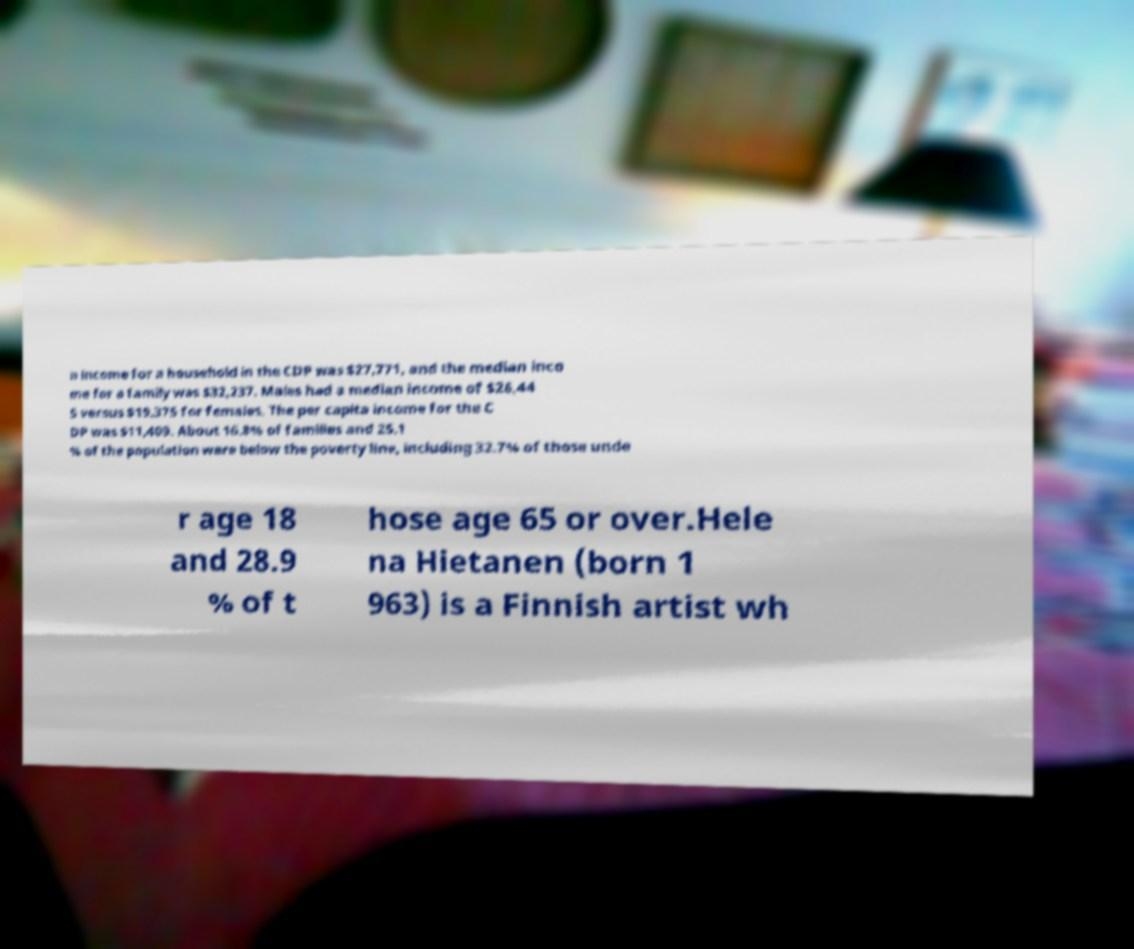Could you extract and type out the text from this image? n income for a household in the CDP was $27,771, and the median inco me for a family was $32,237. Males had a median income of $26,44 5 versus $19,375 for females. The per capita income for the C DP was $11,409. About 16.8% of families and 25.1 % of the population were below the poverty line, including 32.7% of those unde r age 18 and 28.9 % of t hose age 65 or over.Hele na Hietanen (born 1 963) is a Finnish artist wh 